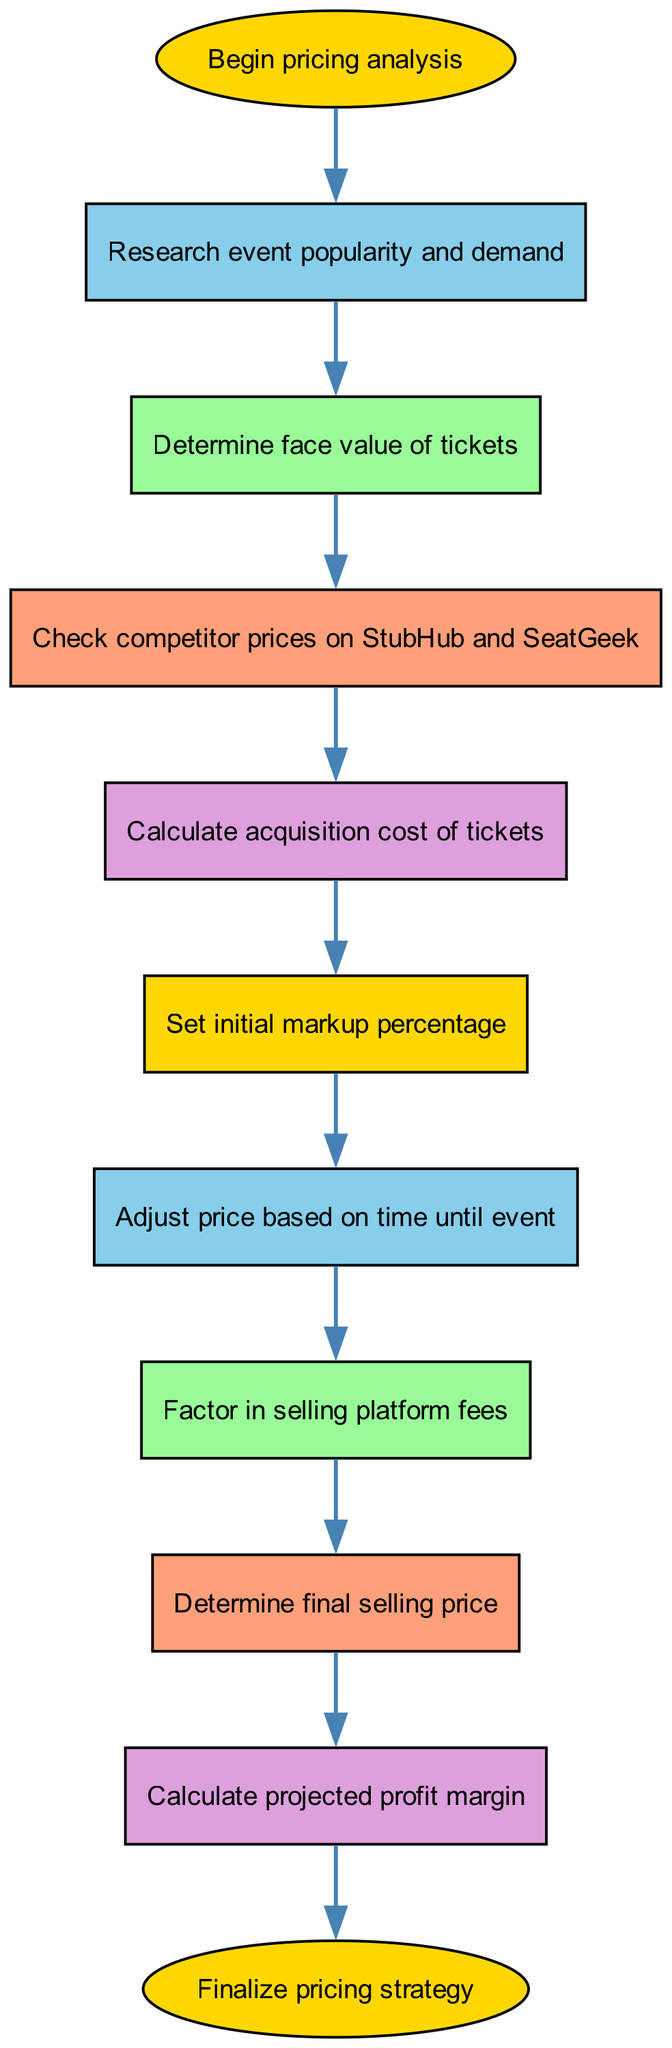What is the first step in the pricing analysis process? The first step indicated in the diagram is "Begin pricing analysis," which is labeled as the starting point of the flow.
Answer: Begin pricing analysis How many steps are there in the diagram? By counting the nodes from the diagram, there are a total of 10 distinct steps involved in the pricing analysis process.
Answer: 10 Which step comes after determining face value of tickets? The diagram shows that after "Determine face value of tickets," the next step is "Check competitor prices on StubHub and SeatGeek."
Answer: Check competitor prices on StubHub and SeatGeek What action is taken after setting the initial markup percentage? According to the flow, after "Set initial markup percentage," the next action is to "Adjust price based on time until event."
Answer: Adjust price based on time until event What is the last step before finalizing the pricing strategy? The diagram indicates that the step before "Finalize pricing strategy" is to "Calculate projected profit margin."
Answer: Calculate projected profit margin If acquisition cost is higher than competitor prices, what might you need to do? The flow chart suggests that you might need to adjust the price based on various factors like competitor prices and time until the event, ultimately affecting the final selling price.
Answer: Adjust the price What factors are considered when determining the final selling price? The diagram indicates considering the initial markup, time until the event, and platform fees all contribute to determining the final selling price.
Answer: Initial markup, time, platform fees Which step involves checking competitor prices? According to the flow, the step that involves checking competitor prices is "Check competitor prices on StubHub and SeatGeek."
Answer: Check competitor prices on StubHub and SeatGeek What is the purpose of factoring in selling platform fees? The purpose of factoring in selling platform fees is to account for additional costs that could affect the profitability of the resale price set for the tickets.
Answer: Account for additional costs 